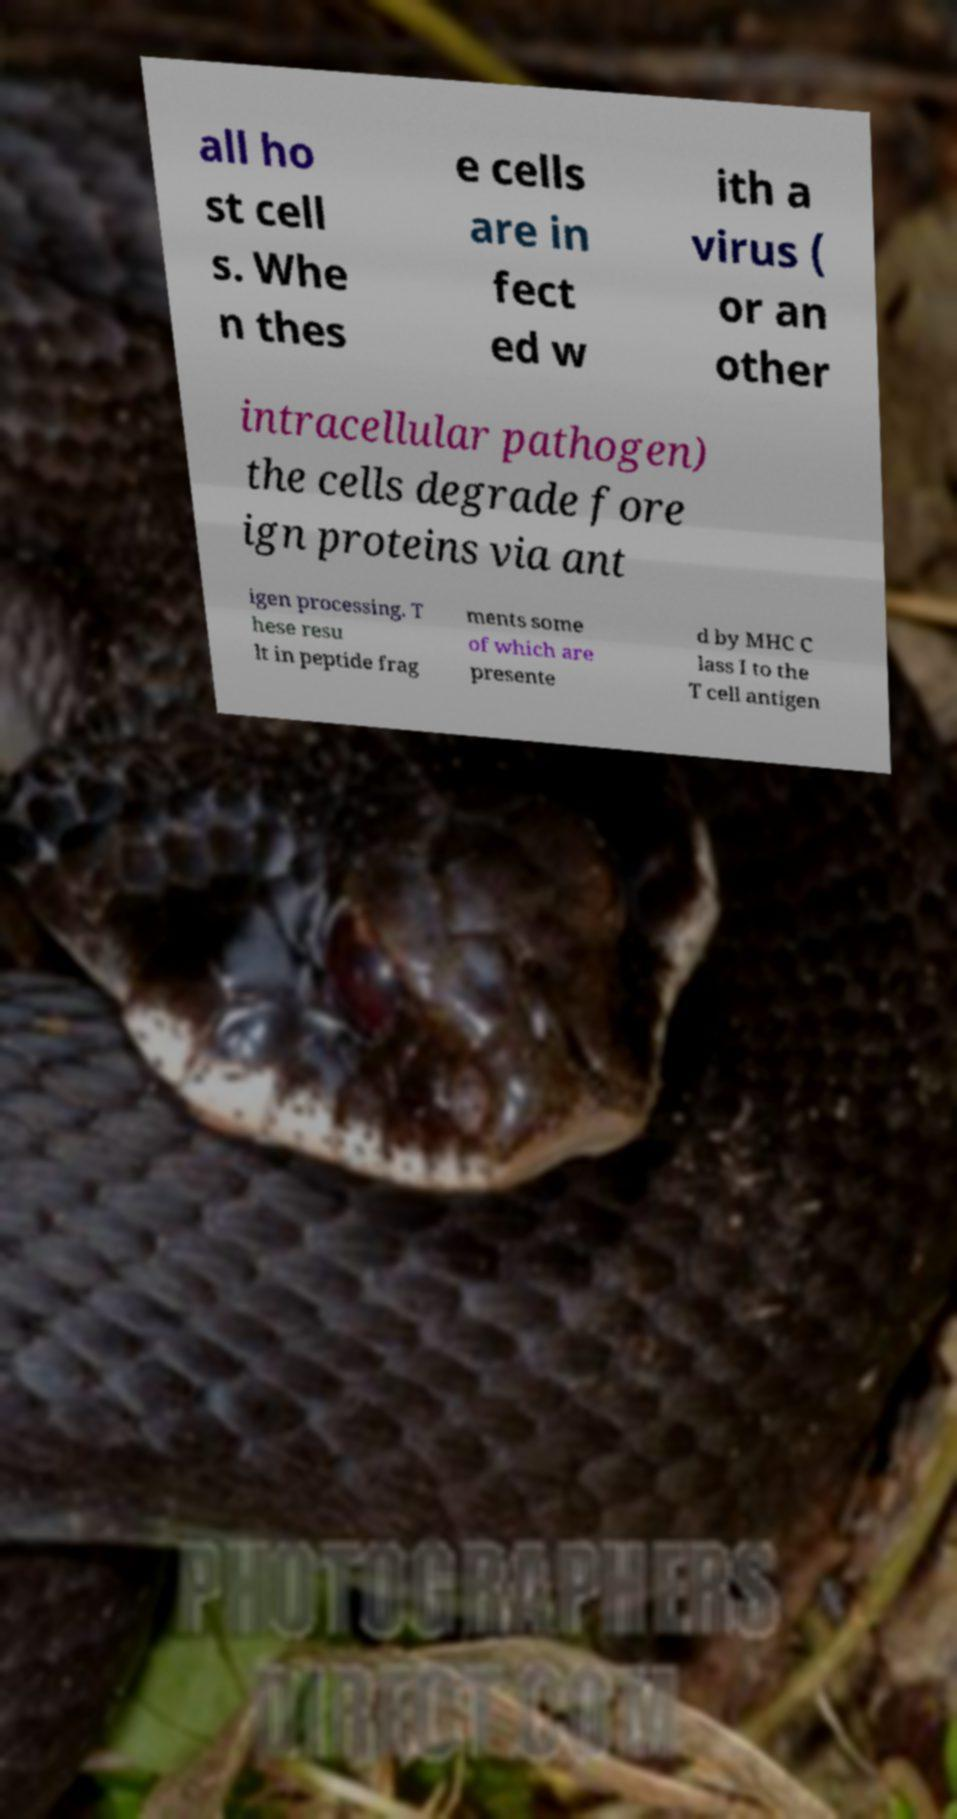Could you extract and type out the text from this image? all ho st cell s. Whe n thes e cells are in fect ed w ith a virus ( or an other intracellular pathogen) the cells degrade fore ign proteins via ant igen processing. T hese resu lt in peptide frag ments some of which are presente d by MHC C lass I to the T cell antigen 